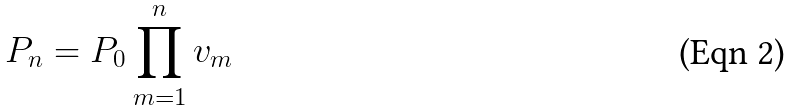<formula> <loc_0><loc_0><loc_500><loc_500>P _ { n } = P _ { 0 } \prod _ { m = 1 } ^ { n } v _ { m }</formula> 